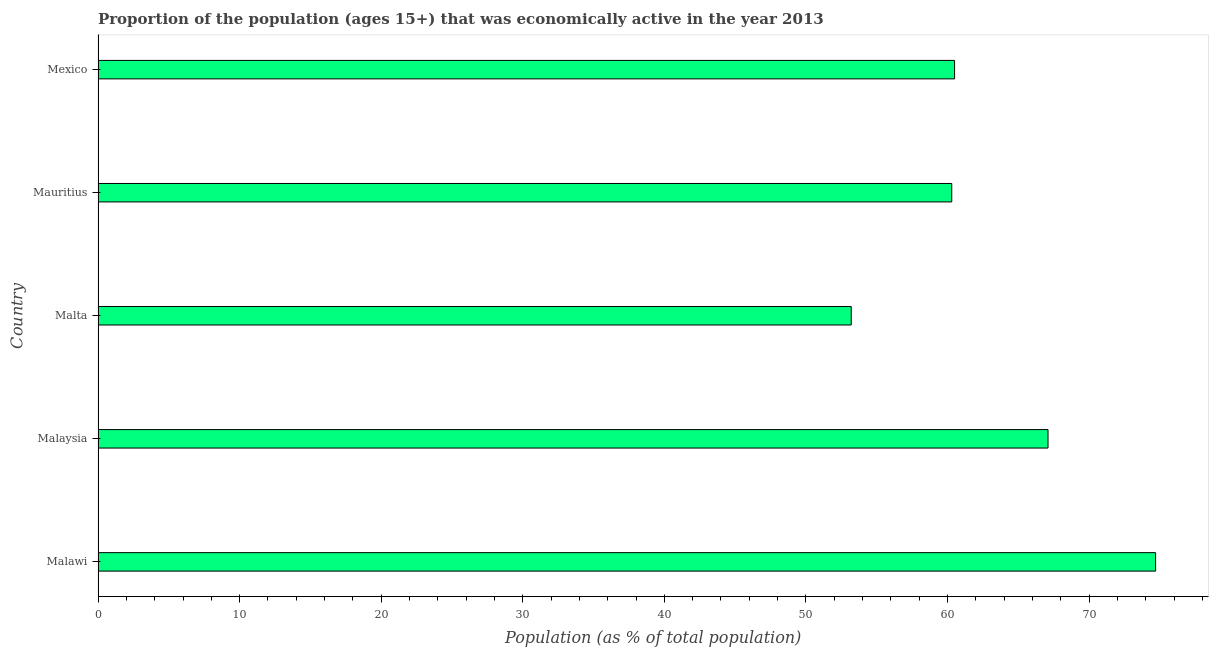Does the graph contain any zero values?
Your response must be concise. No. Does the graph contain grids?
Your answer should be very brief. No. What is the title of the graph?
Provide a succinct answer. Proportion of the population (ages 15+) that was economically active in the year 2013. What is the label or title of the X-axis?
Offer a terse response. Population (as % of total population). What is the label or title of the Y-axis?
Provide a succinct answer. Country. What is the percentage of economically active population in Mauritius?
Your answer should be very brief. 60.3. Across all countries, what is the maximum percentage of economically active population?
Provide a short and direct response. 74.7. Across all countries, what is the minimum percentage of economically active population?
Your response must be concise. 53.2. In which country was the percentage of economically active population maximum?
Your response must be concise. Malawi. In which country was the percentage of economically active population minimum?
Your answer should be compact. Malta. What is the sum of the percentage of economically active population?
Your answer should be very brief. 315.8. What is the average percentage of economically active population per country?
Give a very brief answer. 63.16. What is the median percentage of economically active population?
Give a very brief answer. 60.5. In how many countries, is the percentage of economically active population greater than 48 %?
Provide a succinct answer. 5. What is the ratio of the percentage of economically active population in Malawi to that in Malaysia?
Give a very brief answer. 1.11. Is the difference between the percentage of economically active population in Mauritius and Mexico greater than the difference between any two countries?
Make the answer very short. No. What is the difference between the highest and the second highest percentage of economically active population?
Give a very brief answer. 7.6. Is the sum of the percentage of economically active population in Malta and Mexico greater than the maximum percentage of economically active population across all countries?
Offer a very short reply. Yes. What is the difference between the highest and the lowest percentage of economically active population?
Provide a succinct answer. 21.5. In how many countries, is the percentage of economically active population greater than the average percentage of economically active population taken over all countries?
Keep it short and to the point. 2. Are all the bars in the graph horizontal?
Offer a terse response. Yes. What is the Population (as % of total population) of Malawi?
Ensure brevity in your answer.  74.7. What is the Population (as % of total population) in Malaysia?
Your response must be concise. 67.1. What is the Population (as % of total population) in Malta?
Offer a terse response. 53.2. What is the Population (as % of total population) in Mauritius?
Keep it short and to the point. 60.3. What is the Population (as % of total population) of Mexico?
Offer a terse response. 60.5. What is the difference between the Population (as % of total population) in Malawi and Mauritius?
Provide a short and direct response. 14.4. What is the difference between the Population (as % of total population) in Malaysia and Malta?
Provide a short and direct response. 13.9. What is the difference between the Population (as % of total population) in Malaysia and Mauritius?
Provide a succinct answer. 6.8. What is the difference between the Population (as % of total population) in Malta and Mauritius?
Offer a very short reply. -7.1. What is the ratio of the Population (as % of total population) in Malawi to that in Malaysia?
Make the answer very short. 1.11. What is the ratio of the Population (as % of total population) in Malawi to that in Malta?
Offer a very short reply. 1.4. What is the ratio of the Population (as % of total population) in Malawi to that in Mauritius?
Provide a succinct answer. 1.24. What is the ratio of the Population (as % of total population) in Malawi to that in Mexico?
Offer a very short reply. 1.24. What is the ratio of the Population (as % of total population) in Malaysia to that in Malta?
Ensure brevity in your answer.  1.26. What is the ratio of the Population (as % of total population) in Malaysia to that in Mauritius?
Your response must be concise. 1.11. What is the ratio of the Population (as % of total population) in Malaysia to that in Mexico?
Offer a terse response. 1.11. What is the ratio of the Population (as % of total population) in Malta to that in Mauritius?
Your response must be concise. 0.88. What is the ratio of the Population (as % of total population) in Malta to that in Mexico?
Offer a terse response. 0.88. What is the ratio of the Population (as % of total population) in Mauritius to that in Mexico?
Offer a very short reply. 1. 